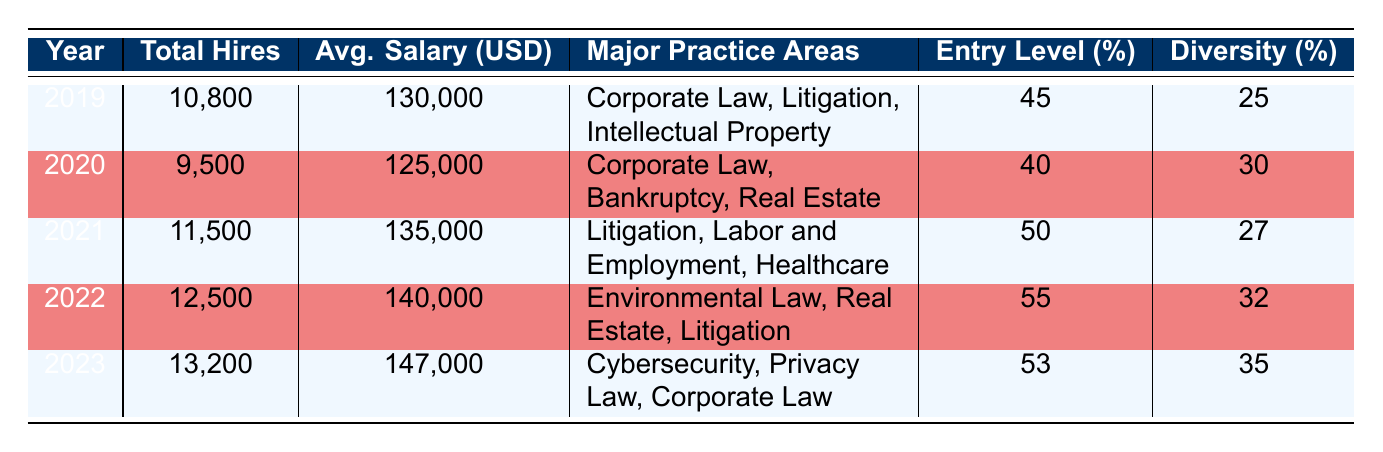What was the total number of hires in 2022? The table indicates that in the year 2022, the Total Hires listed is 12,500.
Answer: 12,500 What was the average salary for law firm hires in 2021? According to the table, the Average Salary for 2021 is 135,000 USD.
Answer: 135,000 USD Which year had the highest percentage of entry-level hires? The table shows that the highest percentage of entry-level hires was in 2022, with 55%.
Answer: 55% How many total hires were recorded from 2019 to 2021? To find the total hires from 2019 to 2021, we sum the Total Hires for each year: 10,800 (2019) + 9,500 (2020) + 11,500 (2021) = 31,800.
Answer: 31,800 Was the percentage of diversity hires higher in 2023 than in 2019? The table shows that the Diversity Hires Percentage in 2019 was 25% and in 2023 it was 35%. Since 35% is greater than 25%, the statement is true.
Answer: Yes Which major practice area appeared in both 2022 and 2021? In comparing the Major Practice Areas, "Litigation" is listed for both 2021 and 2022.
Answer: Litigation What is the average increase in salaries from 2019 to 2023? To find the average increase, we calculate the difference in salaries: 147,000 (2023) - 130,000 (2019) = 17,000. Then, we divide by the number of years (4) between 2019 and 2023: 17,000 / 4 = 4,250.
Answer: 4,250 Did the total number of hires decrease from 2019 to 2020? The Total Hires in 2019 were 10,800 and in 2020 they were 9,500. Since 9,500 is less than 10,800, the statement is true.
Answer: Yes What was the change in the percentage of diversity hires from 2021 to 2022? The percentage of diversity hires in 2021 was 27%, and in 2022 it was 32%. To find the change, we subtract: 32% - 27% = 5%.
Answer: 5% 